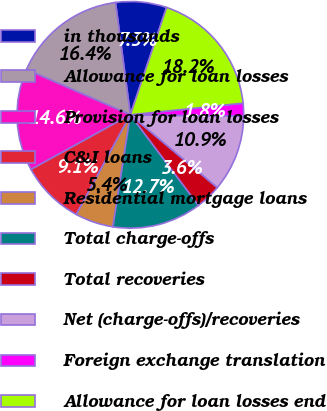Convert chart to OTSL. <chart><loc_0><loc_0><loc_500><loc_500><pie_chart><fcel>in thousands<fcel>Allowance for loan losses<fcel>Provision for loan losses<fcel>C&I loans<fcel>Residential mortgage loans<fcel>Total charge-offs<fcel>Total recoveries<fcel>Net (charge-offs)/recoveries<fcel>Foreign exchange translation<fcel>Allowance for loan losses end<nl><fcel>7.27%<fcel>16.36%<fcel>14.55%<fcel>9.09%<fcel>5.45%<fcel>12.73%<fcel>3.64%<fcel>10.91%<fcel>1.82%<fcel>18.18%<nl></chart> 